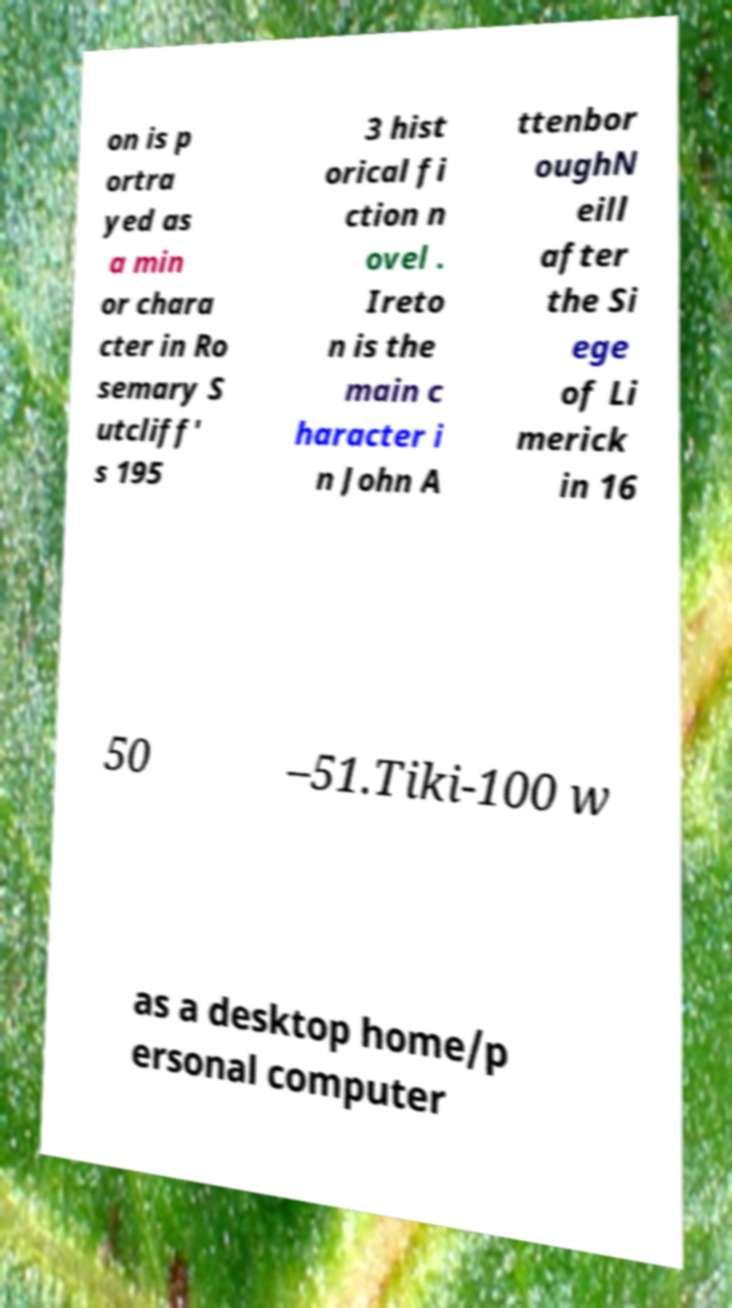What messages or text are displayed in this image? I need them in a readable, typed format. on is p ortra yed as a min or chara cter in Ro semary S utcliff' s 195 3 hist orical fi ction n ovel . Ireto n is the main c haracter i n John A ttenbor oughN eill after the Si ege of Li merick in 16 50 –51.Tiki-100 w as a desktop home/p ersonal computer 